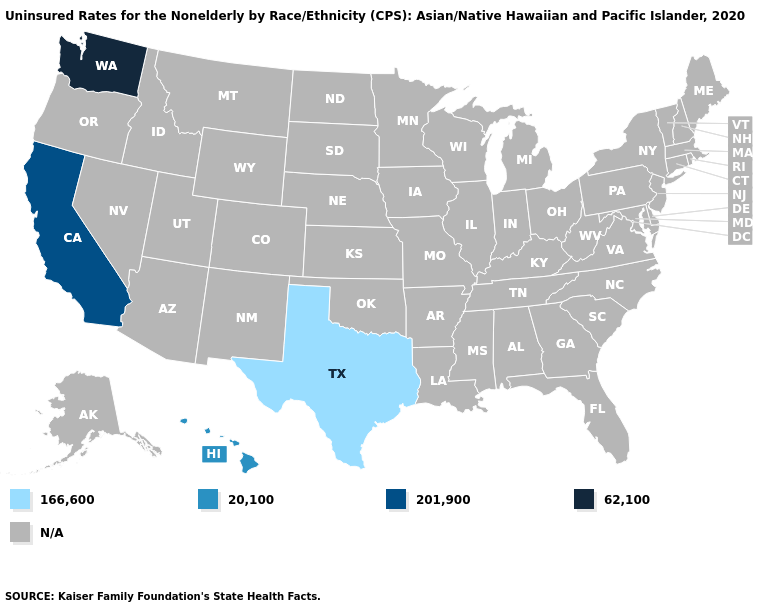What is the lowest value in the South?
Be succinct. 166,600. Name the states that have a value in the range 62,100?
Keep it brief. Washington. Does Texas have the lowest value in the USA?
Answer briefly. Yes. What is the value of Pennsylvania?
Give a very brief answer. N/A. What is the lowest value in the USA?
Concise answer only. 166,600. What is the value of Wyoming?
Give a very brief answer. N/A. Name the states that have a value in the range 20,100?
Keep it brief. Hawaii. Name the states that have a value in the range 62,100?
Be succinct. Washington. Name the states that have a value in the range 62,100?
Concise answer only. Washington. What is the value of Louisiana?
Keep it brief. N/A. Name the states that have a value in the range 201,900?
Quick response, please. California. What is the value of Idaho?
Be succinct. N/A. Name the states that have a value in the range 20,100?
Write a very short answer. Hawaii. 